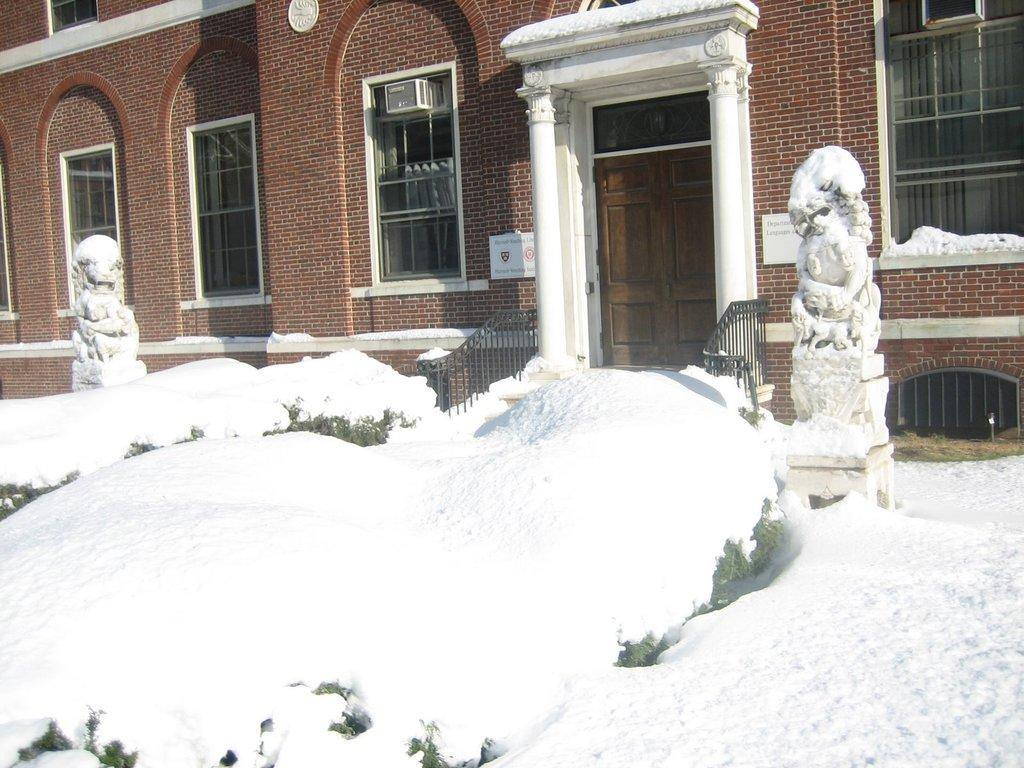What type of structure is visible in the image? There is a building in the image. What features can be seen on the building? The building has windows and a door. What is present around the building? There is a fence in the image. What is the weather like in the image? There is snow in the image, and it is white in color. What else can be seen in the image besides the building and snow? There are sculptures in the image. What type of rabbit can be seen in the image? There is no rabbit present in the image. What class is the chicken attending in the image? There is no chicken or class present in the image. 